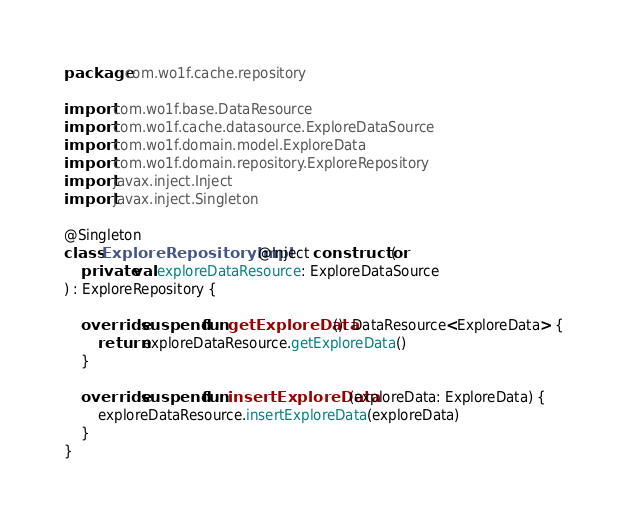<code> <loc_0><loc_0><loc_500><loc_500><_Kotlin_>package com.wo1f.cache.repository

import com.wo1f.base.DataResource
import com.wo1f.cache.datasource.ExploreDataSource
import com.wo1f.domain.model.ExploreData
import com.wo1f.domain.repository.ExploreRepository
import javax.inject.Inject
import javax.inject.Singleton

@Singleton
class ExploreRepositoryImpl @Inject constructor(
    private val exploreDataResource: ExploreDataSource
) : ExploreRepository {

    override suspend fun getExploreData(): DataResource<ExploreData> {
        return exploreDataResource.getExploreData()
    }

    override suspend fun insertExploreData(exploreData: ExploreData) {
        exploreDataResource.insertExploreData(exploreData)
    }
}
</code> 